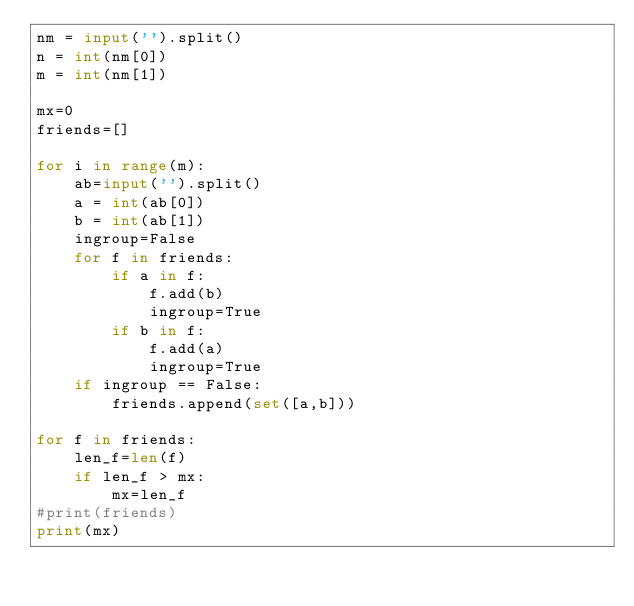<code> <loc_0><loc_0><loc_500><loc_500><_Python_>nm = input('').split()
n = int(nm[0])
m = int(nm[1])

mx=0
friends=[]

for i in range(m):
    ab=input('').split()
    a = int(ab[0])
    b = int(ab[1])
    ingroup=False
    for f in friends:
        if a in f:
            f.add(b)
            ingroup=True
        if b in f:
            f.add(a)
            ingroup=True
    if ingroup == False:
        friends.append(set([a,b]))
    
for f in friends:
    len_f=len(f)
    if len_f > mx:
        mx=len_f
#print(friends)
print(mx)</code> 